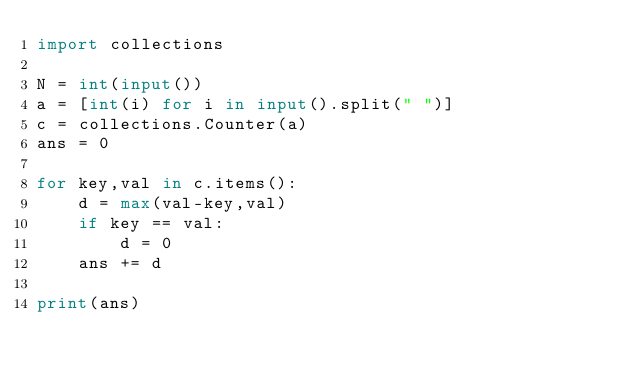<code> <loc_0><loc_0><loc_500><loc_500><_Python_>import collections

N = int(input())
a = [int(i) for i in input().split(" ")]
c = collections.Counter(a)
ans = 0

for key,val in c.items():
    d = max(val-key,val)
    if key == val:
        d = 0
    ans += d

print(ans)
</code> 